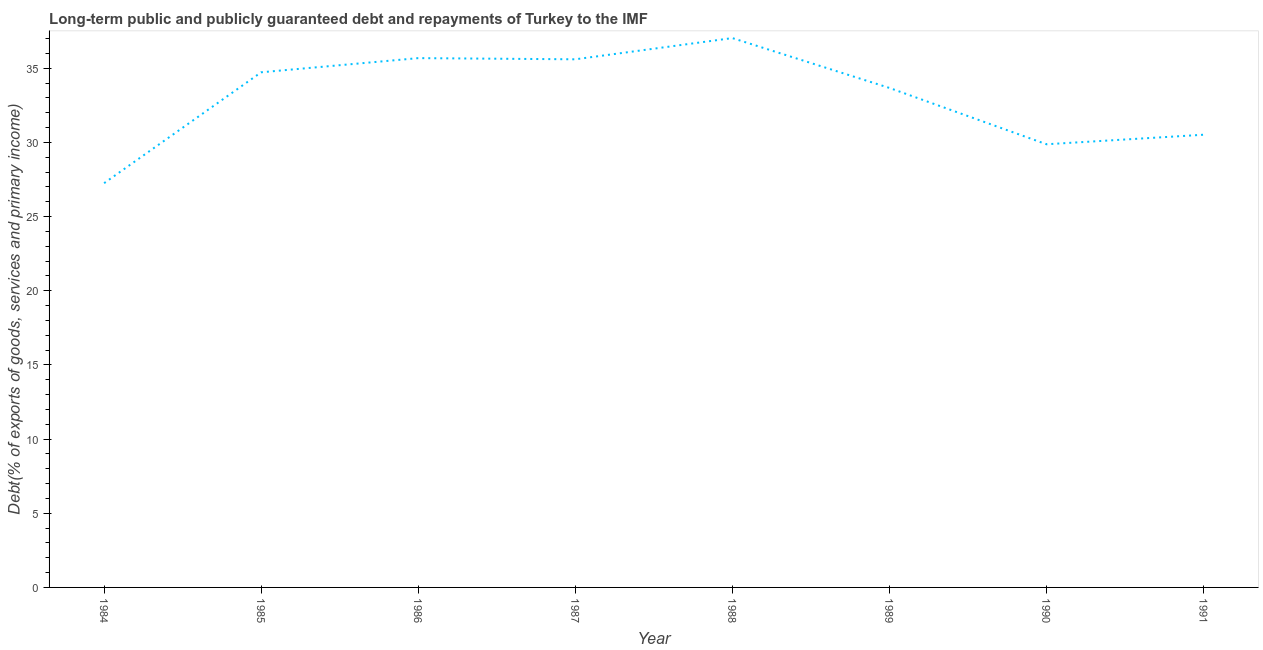What is the debt service in 1986?
Your answer should be very brief. 35.68. Across all years, what is the maximum debt service?
Ensure brevity in your answer.  37.03. Across all years, what is the minimum debt service?
Your answer should be very brief. 27.25. In which year was the debt service minimum?
Make the answer very short. 1984. What is the sum of the debt service?
Keep it short and to the point. 264.37. What is the difference between the debt service in 1986 and 1988?
Offer a very short reply. -1.35. What is the average debt service per year?
Provide a short and direct response. 33.05. What is the median debt service?
Your answer should be very brief. 34.2. Do a majority of the years between 1985 and 1988 (inclusive) have debt service greater than 2 %?
Provide a short and direct response. Yes. What is the ratio of the debt service in 1985 to that in 1986?
Ensure brevity in your answer.  0.97. What is the difference between the highest and the second highest debt service?
Offer a very short reply. 1.35. What is the difference between the highest and the lowest debt service?
Offer a terse response. 9.78. In how many years, is the debt service greater than the average debt service taken over all years?
Offer a terse response. 5. How many lines are there?
Your answer should be very brief. 1. What is the title of the graph?
Your answer should be compact. Long-term public and publicly guaranteed debt and repayments of Turkey to the IMF. What is the label or title of the X-axis?
Keep it short and to the point. Year. What is the label or title of the Y-axis?
Provide a succinct answer. Debt(% of exports of goods, services and primary income). What is the Debt(% of exports of goods, services and primary income) of 1984?
Make the answer very short. 27.25. What is the Debt(% of exports of goods, services and primary income) of 1985?
Provide a short and direct response. 34.73. What is the Debt(% of exports of goods, services and primary income) in 1986?
Your response must be concise. 35.68. What is the Debt(% of exports of goods, services and primary income) of 1987?
Give a very brief answer. 35.6. What is the Debt(% of exports of goods, services and primary income) of 1988?
Offer a terse response. 37.03. What is the Debt(% of exports of goods, services and primary income) of 1989?
Your answer should be very brief. 33.67. What is the Debt(% of exports of goods, services and primary income) in 1990?
Offer a terse response. 29.88. What is the Debt(% of exports of goods, services and primary income) of 1991?
Provide a succinct answer. 30.52. What is the difference between the Debt(% of exports of goods, services and primary income) in 1984 and 1985?
Offer a very short reply. -7.48. What is the difference between the Debt(% of exports of goods, services and primary income) in 1984 and 1986?
Offer a very short reply. -8.43. What is the difference between the Debt(% of exports of goods, services and primary income) in 1984 and 1987?
Give a very brief answer. -8.35. What is the difference between the Debt(% of exports of goods, services and primary income) in 1984 and 1988?
Your answer should be very brief. -9.78. What is the difference between the Debt(% of exports of goods, services and primary income) in 1984 and 1989?
Keep it short and to the point. -6.42. What is the difference between the Debt(% of exports of goods, services and primary income) in 1984 and 1990?
Make the answer very short. -2.62. What is the difference between the Debt(% of exports of goods, services and primary income) in 1984 and 1991?
Make the answer very short. -3.27. What is the difference between the Debt(% of exports of goods, services and primary income) in 1985 and 1986?
Offer a very short reply. -0.96. What is the difference between the Debt(% of exports of goods, services and primary income) in 1985 and 1987?
Your answer should be compact. -0.88. What is the difference between the Debt(% of exports of goods, services and primary income) in 1985 and 1988?
Your answer should be compact. -2.31. What is the difference between the Debt(% of exports of goods, services and primary income) in 1985 and 1989?
Give a very brief answer. 1.05. What is the difference between the Debt(% of exports of goods, services and primary income) in 1985 and 1990?
Offer a terse response. 4.85. What is the difference between the Debt(% of exports of goods, services and primary income) in 1985 and 1991?
Offer a terse response. 4.21. What is the difference between the Debt(% of exports of goods, services and primary income) in 1986 and 1987?
Give a very brief answer. 0.08. What is the difference between the Debt(% of exports of goods, services and primary income) in 1986 and 1988?
Provide a succinct answer. -1.35. What is the difference between the Debt(% of exports of goods, services and primary income) in 1986 and 1989?
Give a very brief answer. 2.01. What is the difference between the Debt(% of exports of goods, services and primary income) in 1986 and 1990?
Provide a succinct answer. 5.81. What is the difference between the Debt(% of exports of goods, services and primary income) in 1986 and 1991?
Provide a succinct answer. 5.16. What is the difference between the Debt(% of exports of goods, services and primary income) in 1987 and 1988?
Your response must be concise. -1.43. What is the difference between the Debt(% of exports of goods, services and primary income) in 1987 and 1989?
Make the answer very short. 1.93. What is the difference between the Debt(% of exports of goods, services and primary income) in 1987 and 1990?
Your response must be concise. 5.73. What is the difference between the Debt(% of exports of goods, services and primary income) in 1987 and 1991?
Offer a terse response. 5.09. What is the difference between the Debt(% of exports of goods, services and primary income) in 1988 and 1989?
Your answer should be very brief. 3.36. What is the difference between the Debt(% of exports of goods, services and primary income) in 1988 and 1990?
Your answer should be compact. 7.16. What is the difference between the Debt(% of exports of goods, services and primary income) in 1988 and 1991?
Offer a terse response. 6.52. What is the difference between the Debt(% of exports of goods, services and primary income) in 1989 and 1990?
Offer a very short reply. 3.8. What is the difference between the Debt(% of exports of goods, services and primary income) in 1989 and 1991?
Provide a succinct answer. 3.16. What is the difference between the Debt(% of exports of goods, services and primary income) in 1990 and 1991?
Your answer should be compact. -0.64. What is the ratio of the Debt(% of exports of goods, services and primary income) in 1984 to that in 1985?
Make the answer very short. 0.79. What is the ratio of the Debt(% of exports of goods, services and primary income) in 1984 to that in 1986?
Keep it short and to the point. 0.76. What is the ratio of the Debt(% of exports of goods, services and primary income) in 1984 to that in 1987?
Offer a terse response. 0.77. What is the ratio of the Debt(% of exports of goods, services and primary income) in 1984 to that in 1988?
Your answer should be very brief. 0.74. What is the ratio of the Debt(% of exports of goods, services and primary income) in 1984 to that in 1989?
Offer a very short reply. 0.81. What is the ratio of the Debt(% of exports of goods, services and primary income) in 1984 to that in 1990?
Offer a terse response. 0.91. What is the ratio of the Debt(% of exports of goods, services and primary income) in 1984 to that in 1991?
Your answer should be very brief. 0.89. What is the ratio of the Debt(% of exports of goods, services and primary income) in 1985 to that in 1986?
Ensure brevity in your answer.  0.97. What is the ratio of the Debt(% of exports of goods, services and primary income) in 1985 to that in 1988?
Make the answer very short. 0.94. What is the ratio of the Debt(% of exports of goods, services and primary income) in 1985 to that in 1989?
Give a very brief answer. 1.03. What is the ratio of the Debt(% of exports of goods, services and primary income) in 1985 to that in 1990?
Your answer should be compact. 1.16. What is the ratio of the Debt(% of exports of goods, services and primary income) in 1985 to that in 1991?
Offer a very short reply. 1.14. What is the ratio of the Debt(% of exports of goods, services and primary income) in 1986 to that in 1987?
Give a very brief answer. 1. What is the ratio of the Debt(% of exports of goods, services and primary income) in 1986 to that in 1988?
Your response must be concise. 0.96. What is the ratio of the Debt(% of exports of goods, services and primary income) in 1986 to that in 1989?
Give a very brief answer. 1.06. What is the ratio of the Debt(% of exports of goods, services and primary income) in 1986 to that in 1990?
Make the answer very short. 1.19. What is the ratio of the Debt(% of exports of goods, services and primary income) in 1986 to that in 1991?
Offer a very short reply. 1.17. What is the ratio of the Debt(% of exports of goods, services and primary income) in 1987 to that in 1989?
Make the answer very short. 1.06. What is the ratio of the Debt(% of exports of goods, services and primary income) in 1987 to that in 1990?
Ensure brevity in your answer.  1.19. What is the ratio of the Debt(% of exports of goods, services and primary income) in 1987 to that in 1991?
Ensure brevity in your answer.  1.17. What is the ratio of the Debt(% of exports of goods, services and primary income) in 1988 to that in 1989?
Give a very brief answer. 1.1. What is the ratio of the Debt(% of exports of goods, services and primary income) in 1988 to that in 1990?
Your response must be concise. 1.24. What is the ratio of the Debt(% of exports of goods, services and primary income) in 1988 to that in 1991?
Your answer should be very brief. 1.21. What is the ratio of the Debt(% of exports of goods, services and primary income) in 1989 to that in 1990?
Offer a very short reply. 1.13. What is the ratio of the Debt(% of exports of goods, services and primary income) in 1989 to that in 1991?
Provide a succinct answer. 1.1. What is the ratio of the Debt(% of exports of goods, services and primary income) in 1990 to that in 1991?
Offer a very short reply. 0.98. 